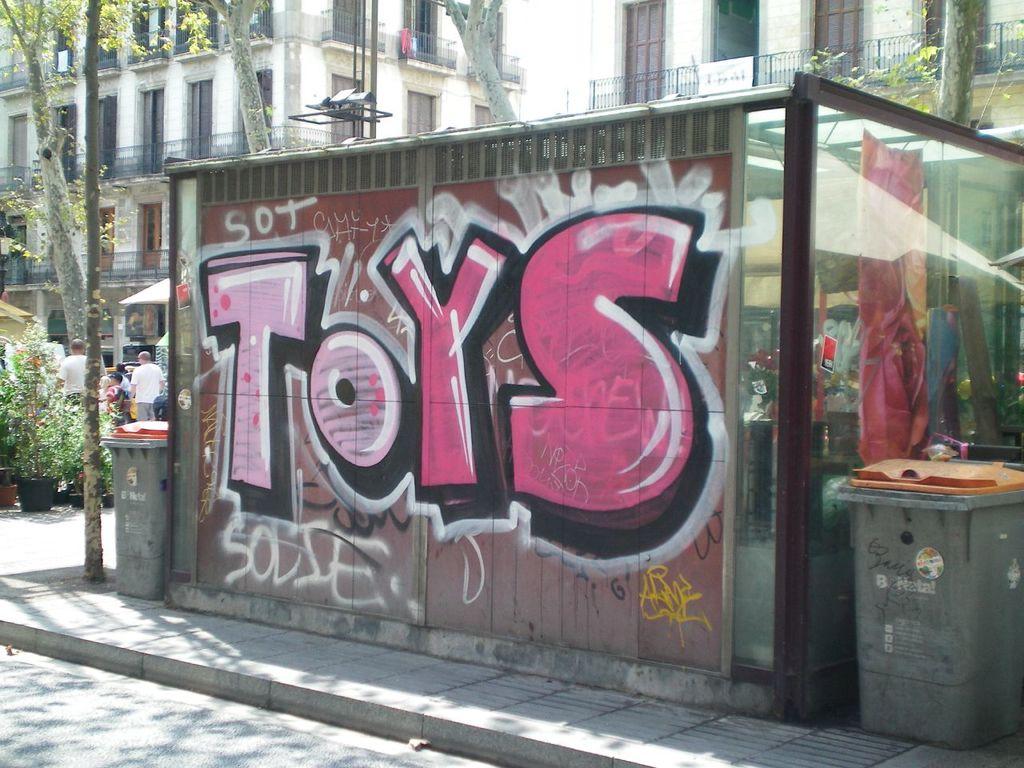What is spray painted on the wall?
Offer a very short reply. Toys. What does it say on top of the large pink letters?
Offer a terse response. Sot. 